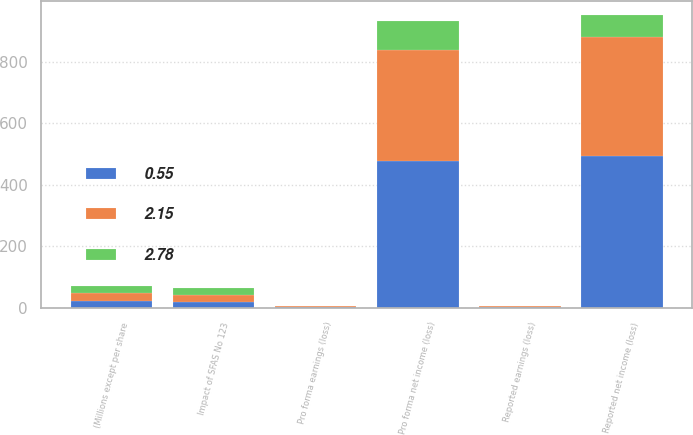Convert chart. <chart><loc_0><loc_0><loc_500><loc_500><stacked_bar_chart><ecel><fcel>(Millions except per share<fcel>Reported net income (loss)<fcel>Impact of SFAS No 123<fcel>Pro forma net income (loss)<fcel>Reported earnings (loss)<fcel>Pro forma earnings (loss)<nl><fcel>0.55<fcel>24<fcel>494<fcel>18<fcel>476<fcel>2.91<fcel>2.8<nl><fcel>2.78<fcel>24<fcel>69<fcel>24<fcel>93<fcel>0.41<fcel>0.55<nl><fcel>2.15<fcel>24<fcel>387<fcel>24<fcel>363<fcel>2.3<fcel>2.16<nl></chart> 